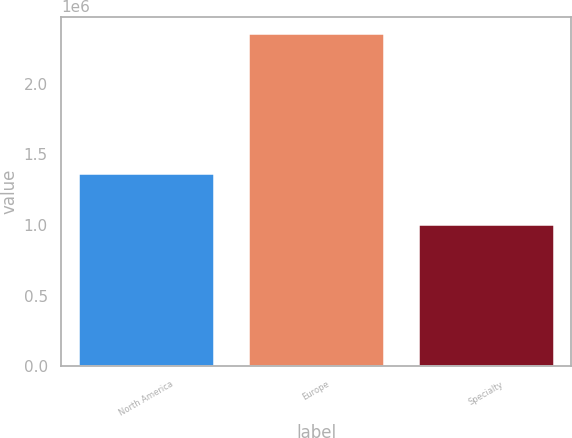Convert chart. <chart><loc_0><loc_0><loc_500><loc_500><bar_chart><fcel>North America<fcel>Europe<fcel>Specialty<nl><fcel>1.3676e+06<fcel>2.3553e+06<fcel>1.0066e+06<nl></chart> 